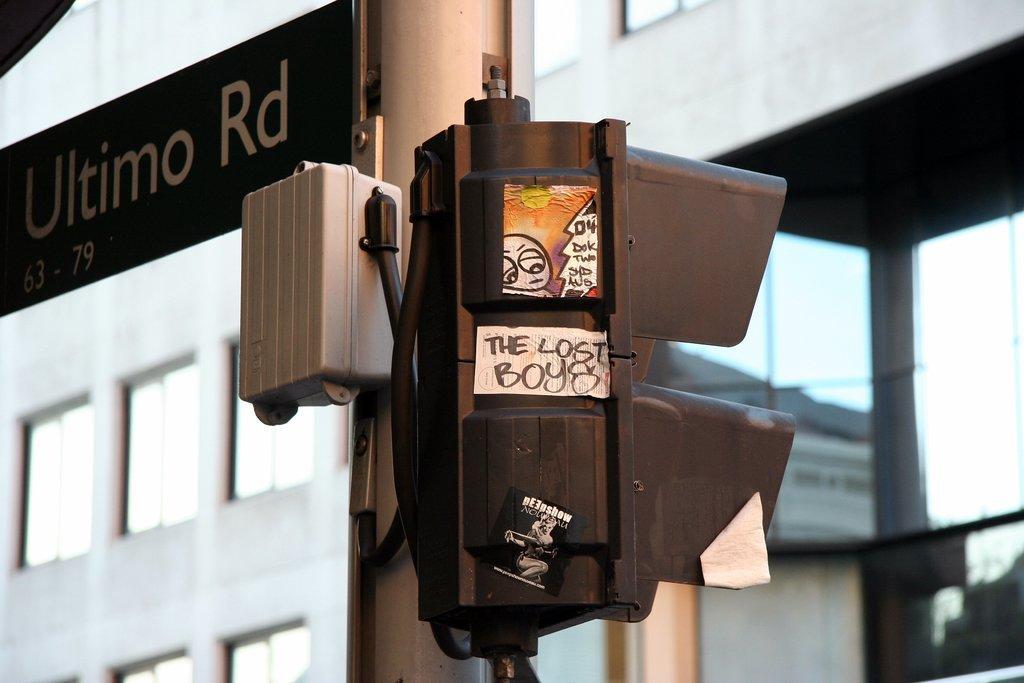Please provide a concise description of this image. This looks like a traffic signal, which is attached to the pole. I think, this is a name board. In the background, that looks like a building with the windows. 